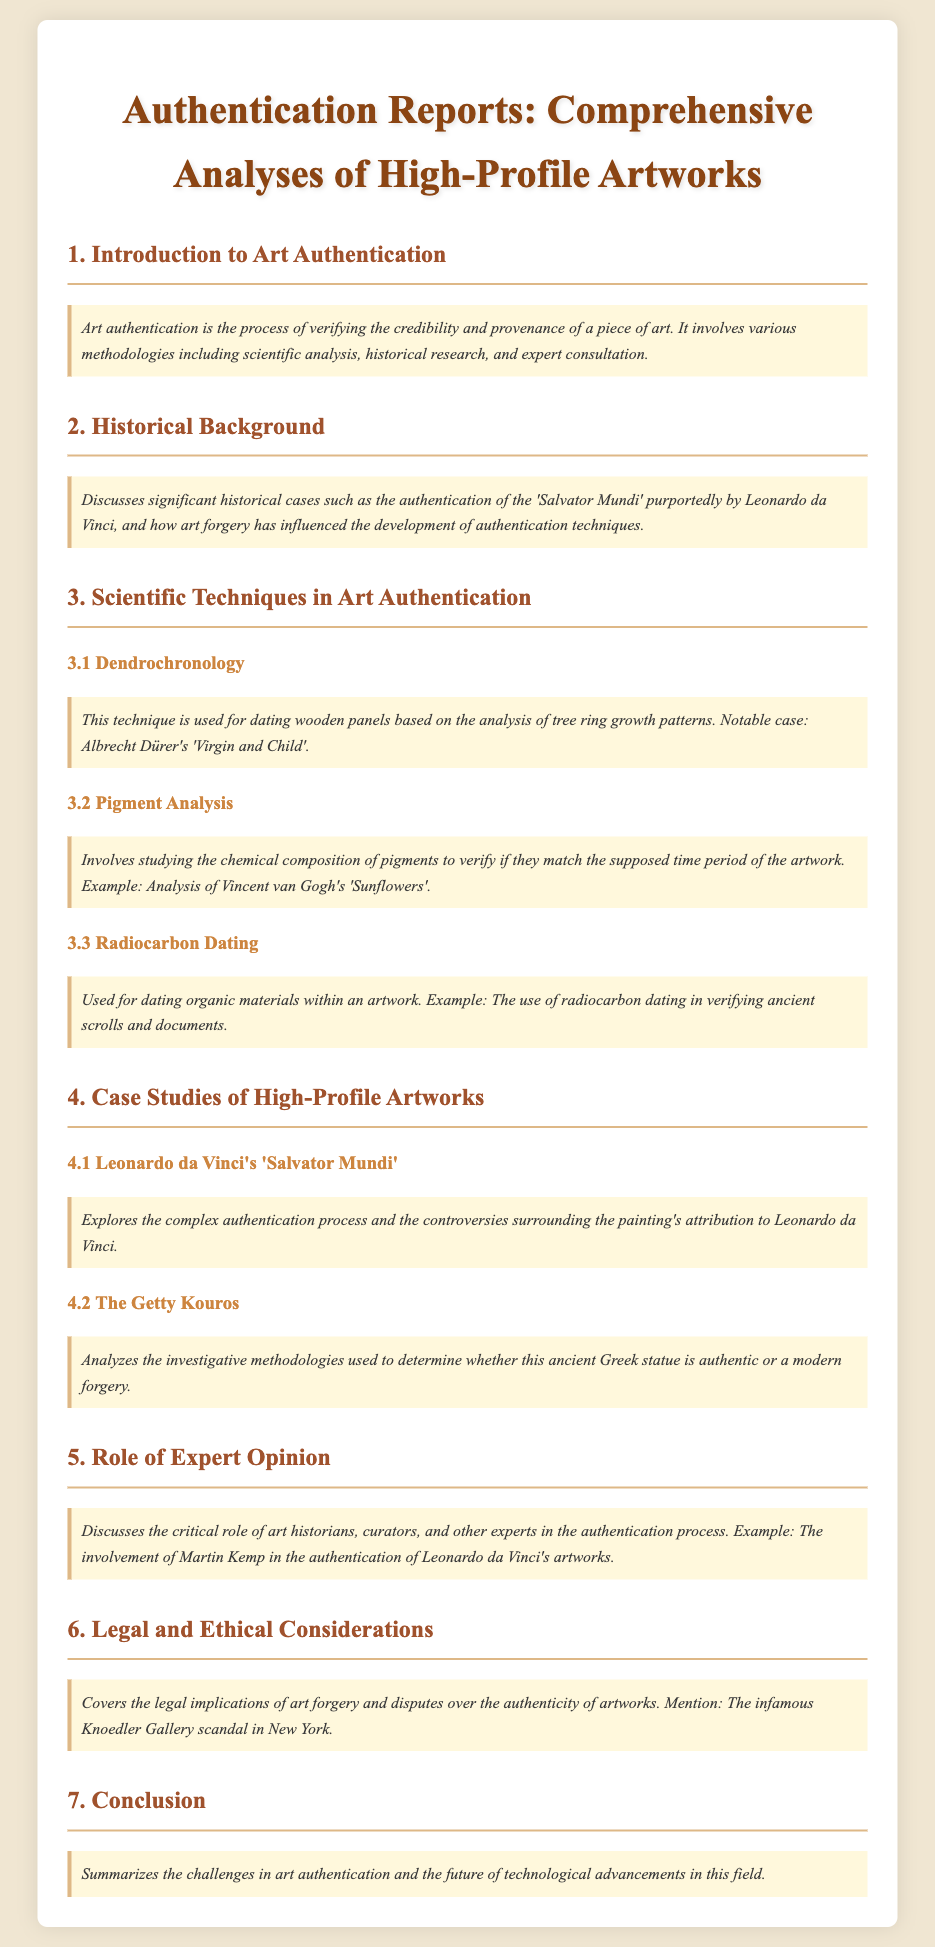What is art authentication? Art authentication is the process of verifying the credibility and provenance of a piece of art.
Answer: Verifying credibility and provenance What historical case is discussed regarding Leonardo da Vinci? The document mentions the authentication of the 'Salvator Mundi', purportedly by Leonardo da Vinci.
Answer: 'Salvator Mundi' What scientific technique involves analyzing tree ring growth patterns? Dendrochronology is the technique used for dating wooden panels based on tree ring growth patterns.
Answer: Dendrochronology Which technique studies the chemical composition of pigments? Pigment analysis involves studying the chemical composition of pigments to verify their match to the period of the artwork.
Answer: Pigment analysis Who is mentioned as being involved in the authentication of Leonardo da Vinci's artworks? Martin Kemp is mentioned for his involvement in the authentication of Leonardo da Vinci's artworks.
Answer: Martin Kemp What legal implications are covered in the document? The document covers the legal implications of art forgery and disputes over artwork authenticity.
Answer: Art forgery Which artwork's authentication process is described as complex? Leonardo da Vinci's 'Salvator Mundi' has a complex authentication process described in the document.
Answer: 'Salvator Mundi' What is the role of expert opinion in art authentication? The document discusses the critical role of art historians, curators, and experts in the authentication process.
Answer: Critical role of experts What summarization is provided in the conclusion? The conclusion summarizes the challenges in art authentication and the future of technological advancements in this field.
Answer: Challenges and technological advancements 